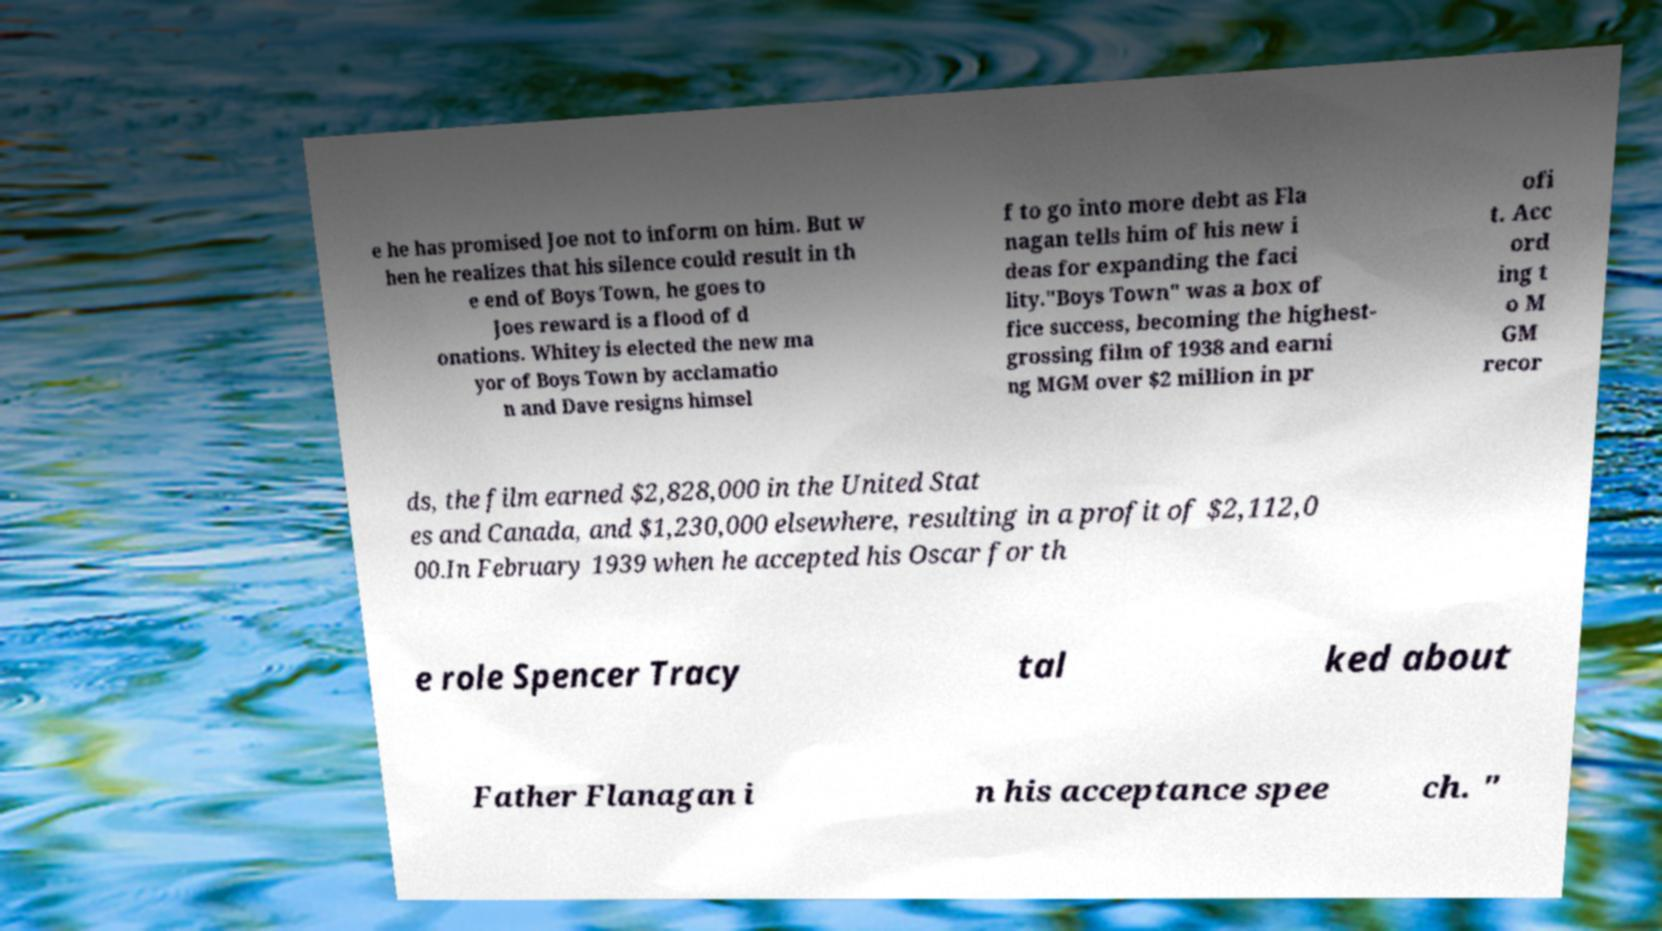For documentation purposes, I need the text within this image transcribed. Could you provide that? e he has promised Joe not to inform on him. But w hen he realizes that his silence could result in th e end of Boys Town, he goes to Joes reward is a flood of d onations. Whitey is elected the new ma yor of Boys Town by acclamatio n and Dave resigns himsel f to go into more debt as Fla nagan tells him of his new i deas for expanding the faci lity."Boys Town" was a box of fice success, becoming the highest- grossing film of 1938 and earni ng MGM over $2 million in pr ofi t. Acc ord ing t o M GM recor ds, the film earned $2,828,000 in the United Stat es and Canada, and $1,230,000 elsewhere, resulting in a profit of $2,112,0 00.In February 1939 when he accepted his Oscar for th e role Spencer Tracy tal ked about Father Flanagan i n his acceptance spee ch. " 